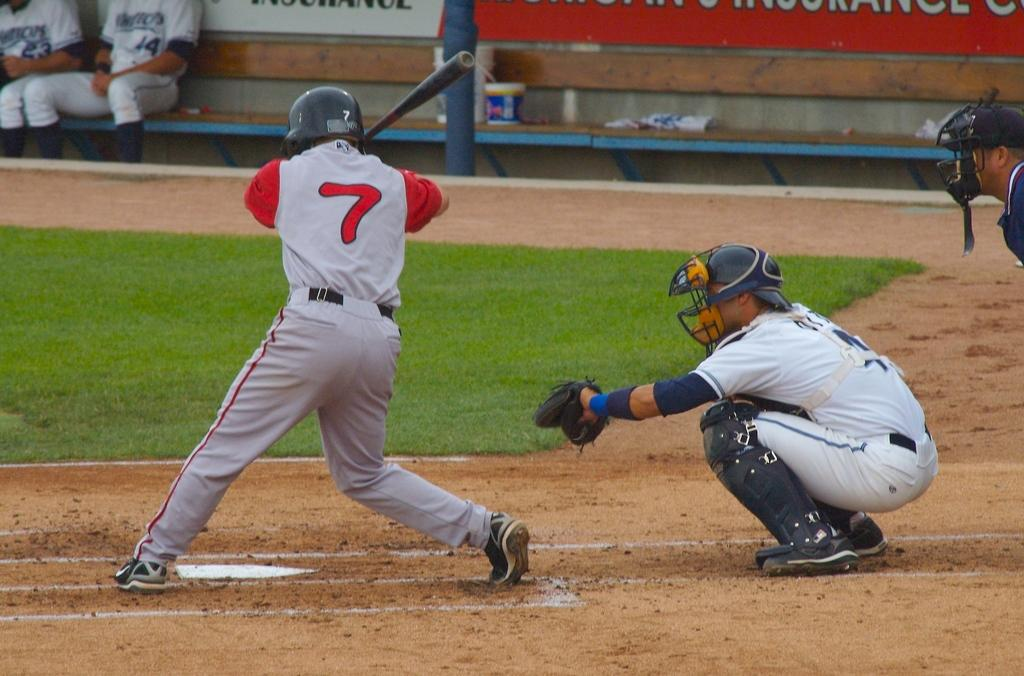<image>
Render a clear and concise summary of the photo. Number 7 is getting ready to swing at a pitch at a baseball game. 